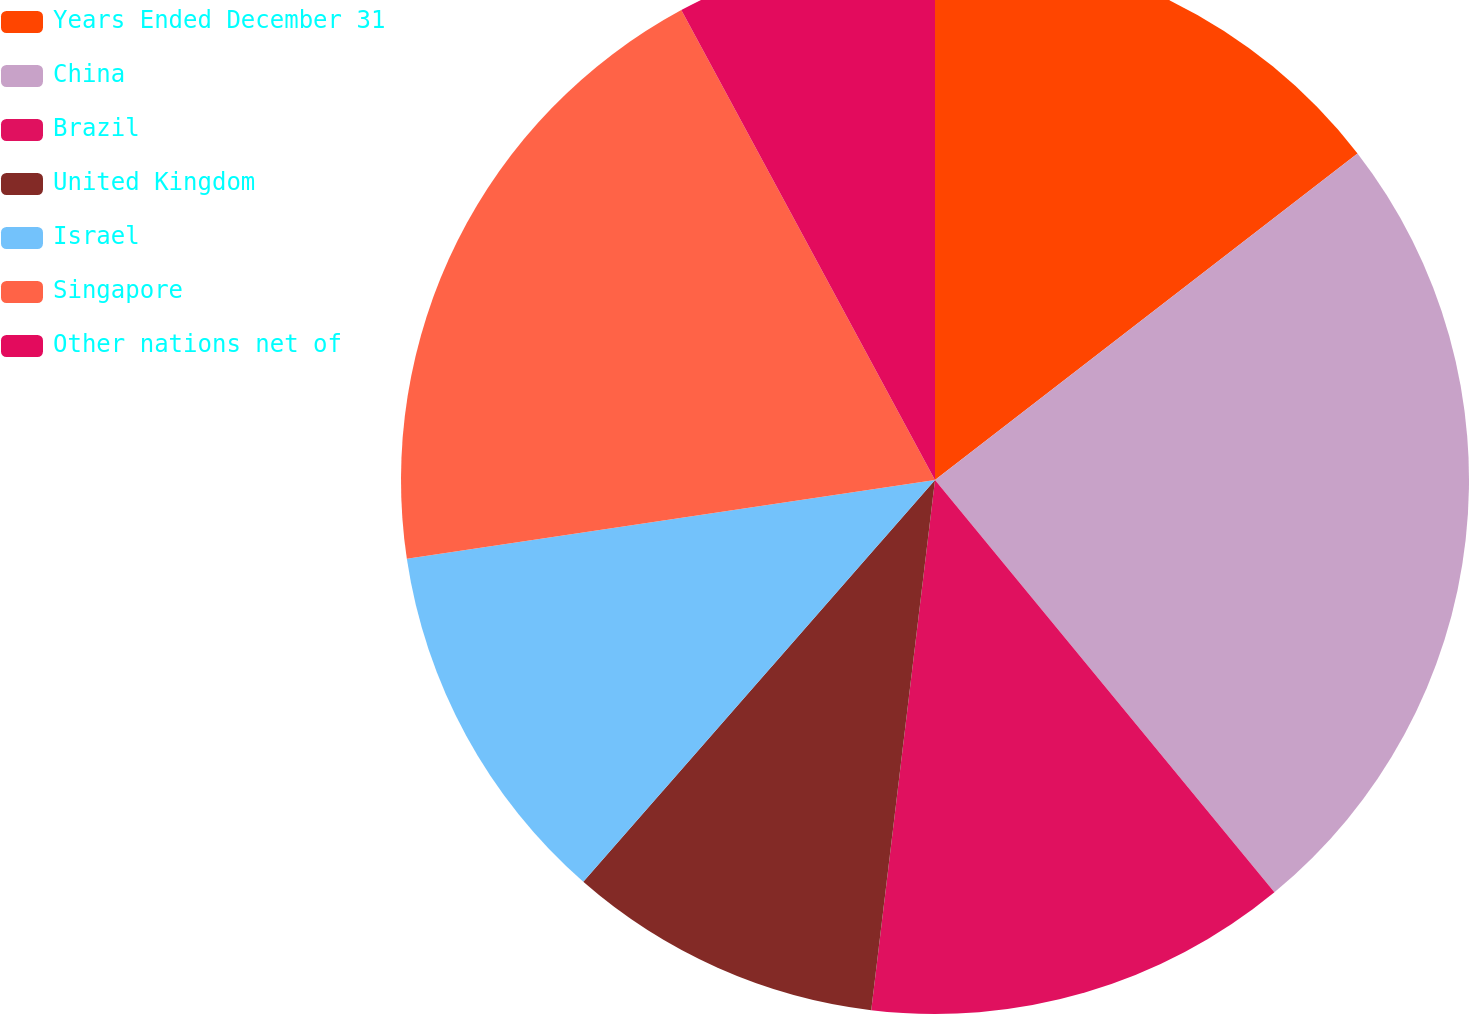Convert chart. <chart><loc_0><loc_0><loc_500><loc_500><pie_chart><fcel>Years Ended December 31<fcel>China<fcel>Brazil<fcel>United Kingdom<fcel>Israel<fcel>Singapore<fcel>Other nations net of<nl><fcel>14.53%<fcel>24.51%<fcel>12.87%<fcel>9.54%<fcel>11.2%<fcel>19.48%<fcel>7.88%<nl></chart> 